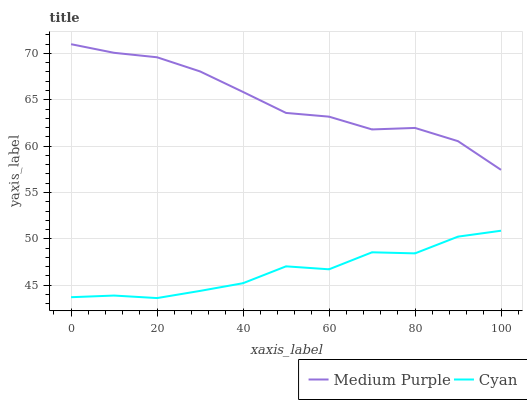Does Cyan have the minimum area under the curve?
Answer yes or no. Yes. Does Medium Purple have the maximum area under the curve?
Answer yes or no. Yes. Does Cyan have the maximum area under the curve?
Answer yes or no. No. Is Medium Purple the smoothest?
Answer yes or no. Yes. Is Cyan the roughest?
Answer yes or no. Yes. Is Cyan the smoothest?
Answer yes or no. No. Does Cyan have the lowest value?
Answer yes or no. Yes. Does Medium Purple have the highest value?
Answer yes or no. Yes. Does Cyan have the highest value?
Answer yes or no. No. Is Cyan less than Medium Purple?
Answer yes or no. Yes. Is Medium Purple greater than Cyan?
Answer yes or no. Yes. Does Cyan intersect Medium Purple?
Answer yes or no. No. 